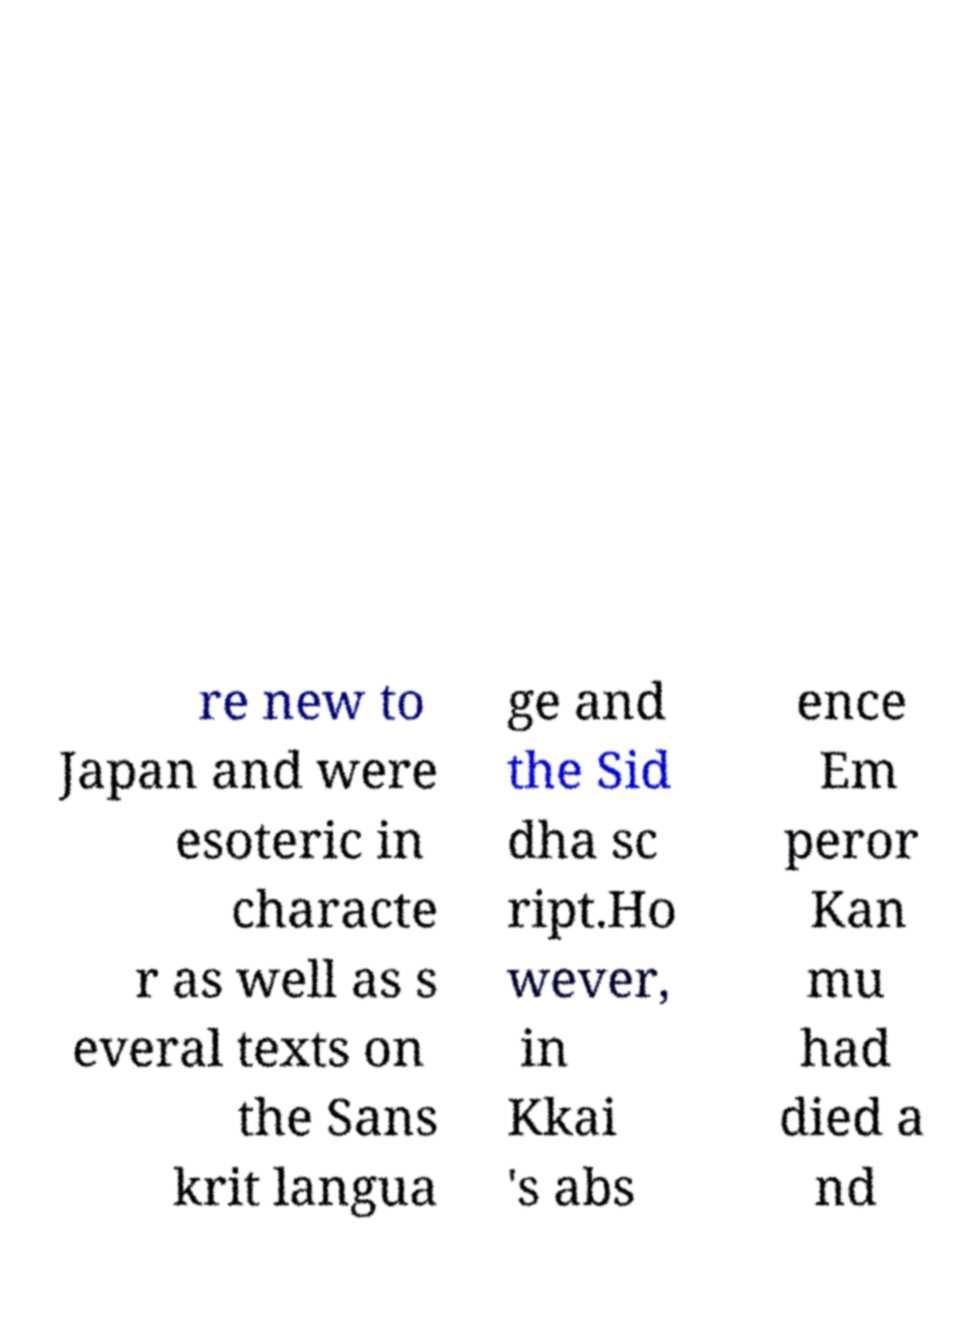What messages or text are displayed in this image? I need them in a readable, typed format. re new to Japan and were esoteric in characte r as well as s everal texts on the Sans krit langua ge and the Sid dha sc ript.Ho wever, in Kkai 's abs ence Em peror Kan mu had died a nd 